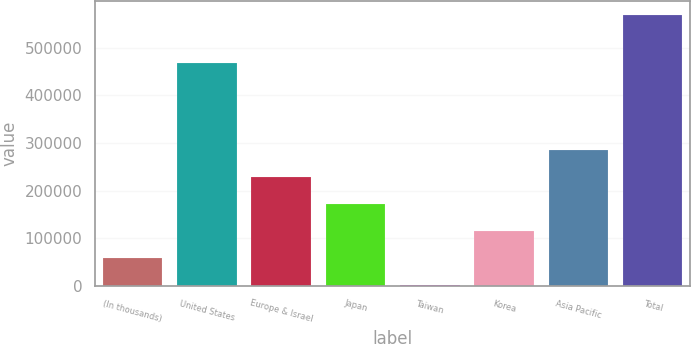Convert chart to OTSL. <chart><loc_0><loc_0><loc_500><loc_500><bar_chart><fcel>(In thousands)<fcel>United States<fcel>Europe & Israel<fcel>Japan<fcel>Taiwan<fcel>Korea<fcel>Asia Pacific<fcel>Total<nl><fcel>58501.3<fcel>468005<fcel>228845<fcel>172064<fcel>1720<fcel>115283<fcel>285626<fcel>569533<nl></chart> 